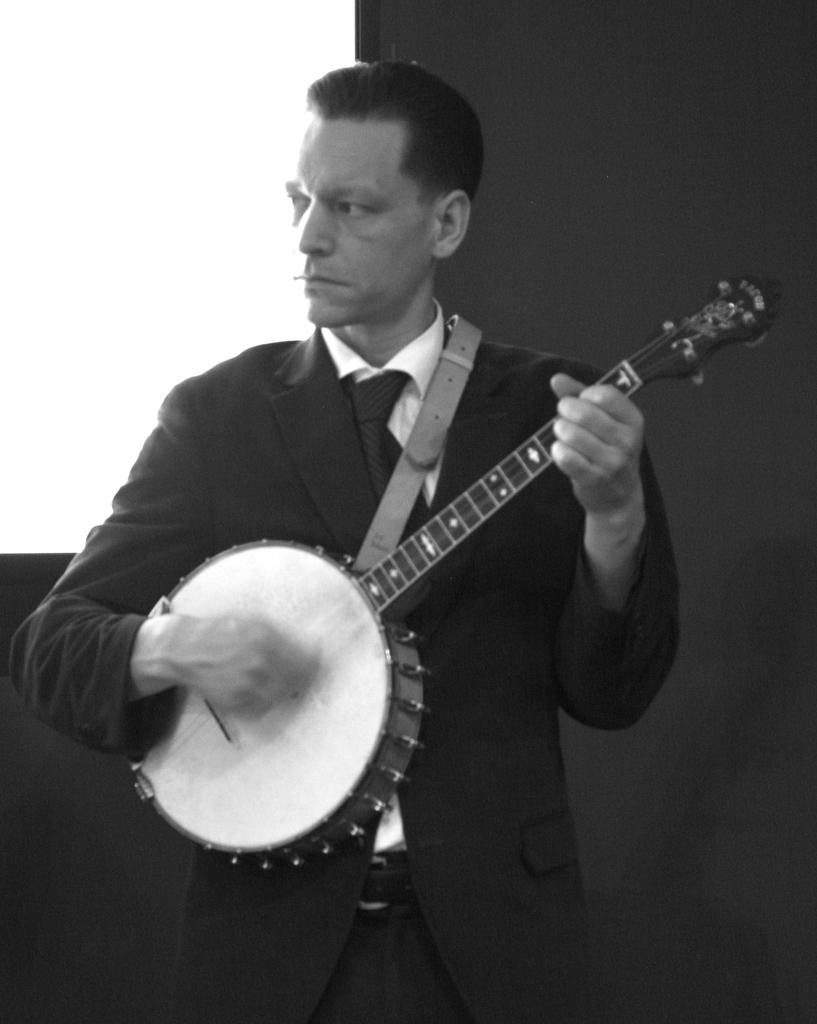What is the main subject of the image? The main subject of the image is a man. What is the man wearing? The man is wearing a suit, a white shirt, a tie, and a belt. What is the man doing in the image? The man is playing a musical instrument and staring at something. How many grapes are hanging from the man's tie in the image? There are no grapes present in the image, nor are they hanging from the man's tie. 